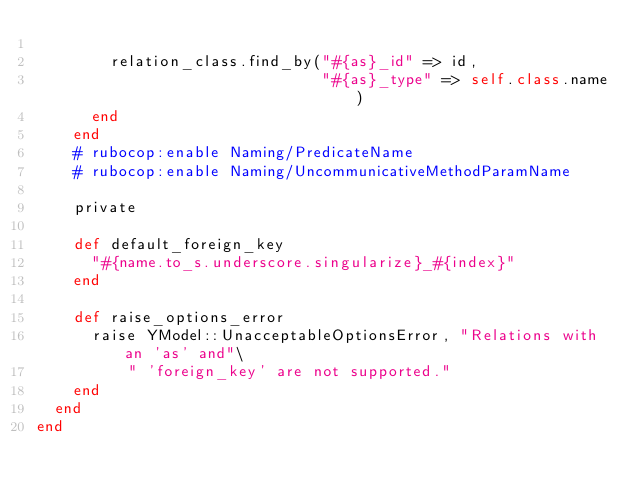Convert code to text. <code><loc_0><loc_0><loc_500><loc_500><_Ruby_>
        relation_class.find_by("#{as}_id" => id,
                               "#{as}_type" => self.class.name)
      end
    end
    # rubocop:enable Naming/PredicateName
    # rubocop:enable Naming/UncommunicativeMethodParamName

    private

    def default_foreign_key
      "#{name.to_s.underscore.singularize}_#{index}"
    end

    def raise_options_error
      raise YModel::UnacceptableOptionsError, "Relations with an 'as' and"\
          " 'foreign_key' are not supported."
    end
  end
end
</code> 